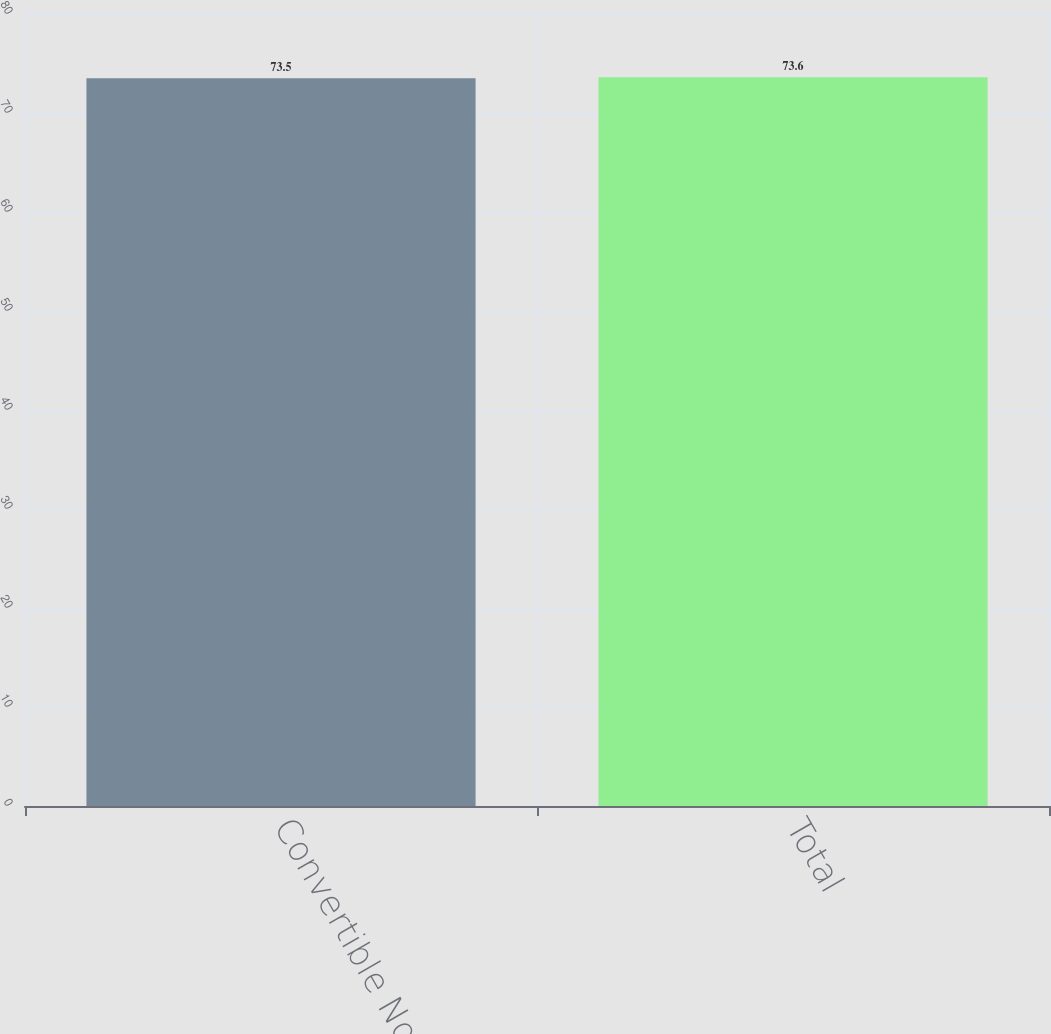Convert chart to OTSL. <chart><loc_0><loc_0><loc_500><loc_500><bar_chart><fcel>Convertible Notes<fcel>Total<nl><fcel>73.5<fcel>73.6<nl></chart> 